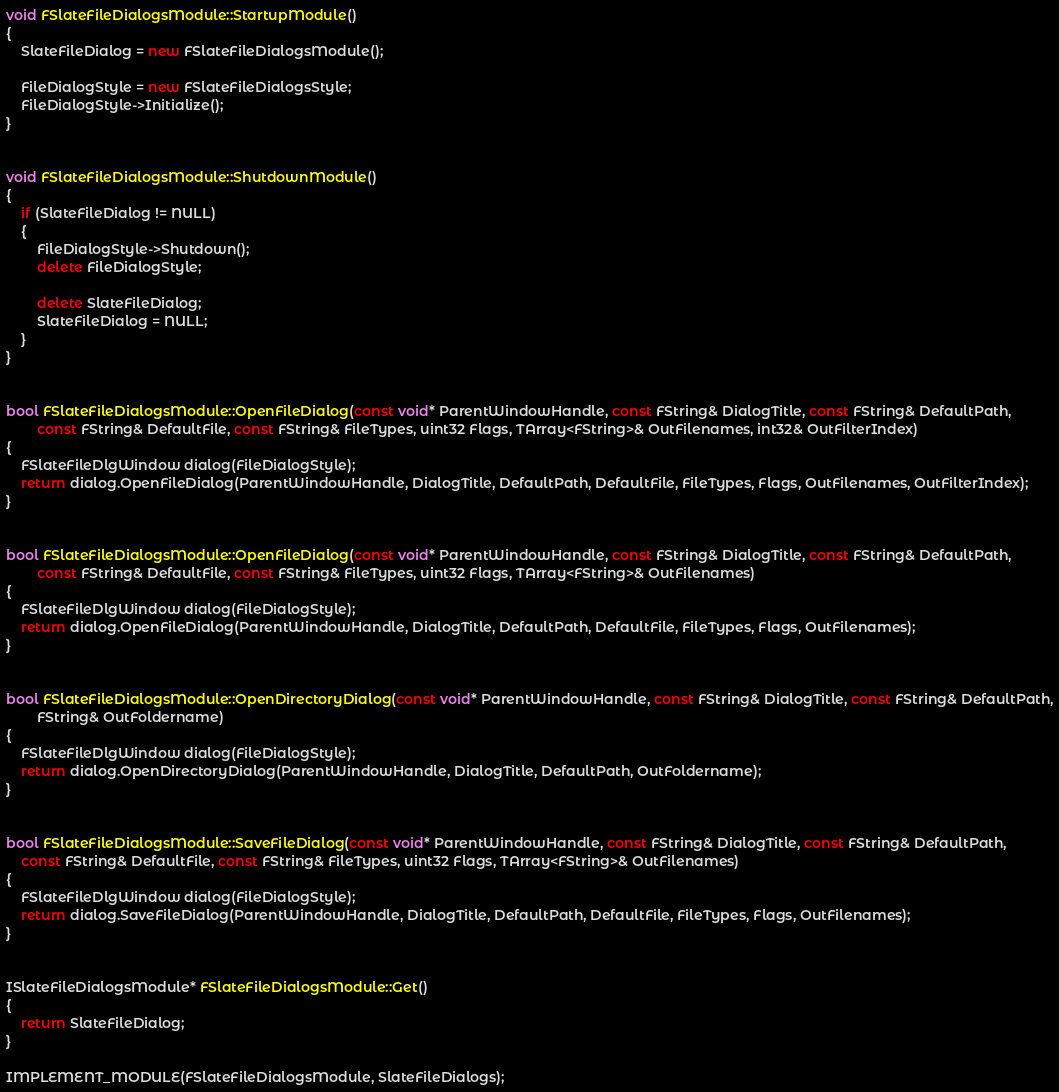Convert code to text. <code><loc_0><loc_0><loc_500><loc_500><_C++_>
void FSlateFileDialogsModule::StartupModule()
{
	SlateFileDialog = new FSlateFileDialogsModule();

	FileDialogStyle = new FSlateFileDialogsStyle;
	FileDialogStyle->Initialize();
}


void FSlateFileDialogsModule::ShutdownModule()
{
	if (SlateFileDialog != NULL)
	{
		FileDialogStyle->Shutdown();
		delete FileDialogStyle;

		delete SlateFileDialog;
		SlateFileDialog = NULL;
	}
}


bool FSlateFileDialogsModule::OpenFileDialog(const void* ParentWindowHandle, const FString& DialogTitle, const FString& DefaultPath,
		const FString& DefaultFile, const FString& FileTypes, uint32 Flags, TArray<FString>& OutFilenames, int32& OutFilterIndex)
{
	FSlateFileDlgWindow dialog(FileDialogStyle);
	return dialog.OpenFileDialog(ParentWindowHandle, DialogTitle, DefaultPath, DefaultFile, FileTypes, Flags, OutFilenames, OutFilterIndex);
}


bool FSlateFileDialogsModule::OpenFileDialog(const void* ParentWindowHandle, const FString& DialogTitle, const FString& DefaultPath,
		const FString& DefaultFile, const FString& FileTypes, uint32 Flags, TArray<FString>& OutFilenames)
{
	FSlateFileDlgWindow dialog(FileDialogStyle);
	return dialog.OpenFileDialog(ParentWindowHandle, DialogTitle, DefaultPath, DefaultFile, FileTypes, Flags, OutFilenames);
}


bool FSlateFileDialogsModule::OpenDirectoryDialog(const void* ParentWindowHandle, const FString& DialogTitle, const FString& DefaultPath,
		FString& OutFoldername)
{
	FSlateFileDlgWindow dialog(FileDialogStyle);
	return dialog.OpenDirectoryDialog(ParentWindowHandle, DialogTitle, DefaultPath, OutFoldername);
}


bool FSlateFileDialogsModule::SaveFileDialog(const void* ParentWindowHandle, const FString& DialogTitle, const FString& DefaultPath,
	const FString& DefaultFile, const FString& FileTypes, uint32 Flags, TArray<FString>& OutFilenames)
{
	FSlateFileDlgWindow dialog(FileDialogStyle);
	return dialog.SaveFileDialog(ParentWindowHandle, DialogTitle, DefaultPath, DefaultFile, FileTypes, Flags, OutFilenames);
}


ISlateFileDialogsModule* FSlateFileDialogsModule::Get()
{
	return SlateFileDialog;
}

IMPLEMENT_MODULE(FSlateFileDialogsModule, SlateFileDialogs);
</code> 